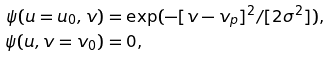Convert formula to latex. <formula><loc_0><loc_0><loc_500><loc_500>\psi ( u = u _ { 0 } , v ) & = \exp ( - [ v - v _ { p } ] ^ { 2 } / [ 2 \sigma ^ { 2 } ] ) \text {,} \\ \psi ( u , v = v _ { 0 } ) & = 0 \text {,}</formula> 